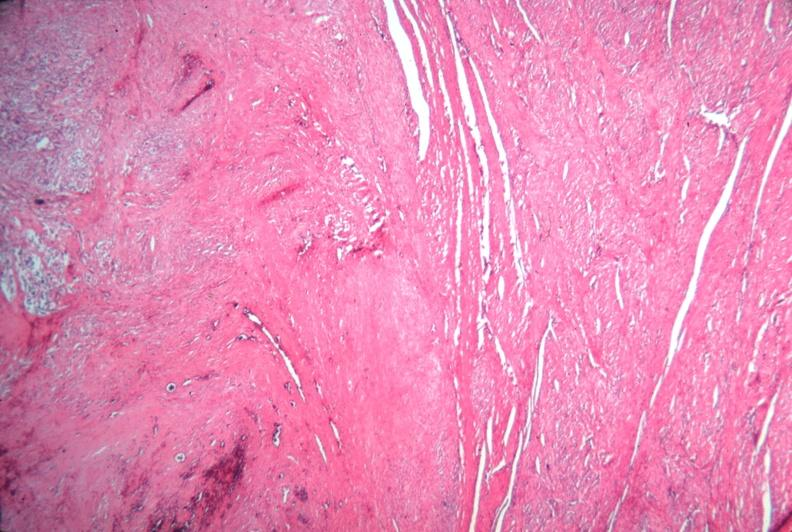s female reproductive present?
Answer the question using a single word or phrase. Yes 